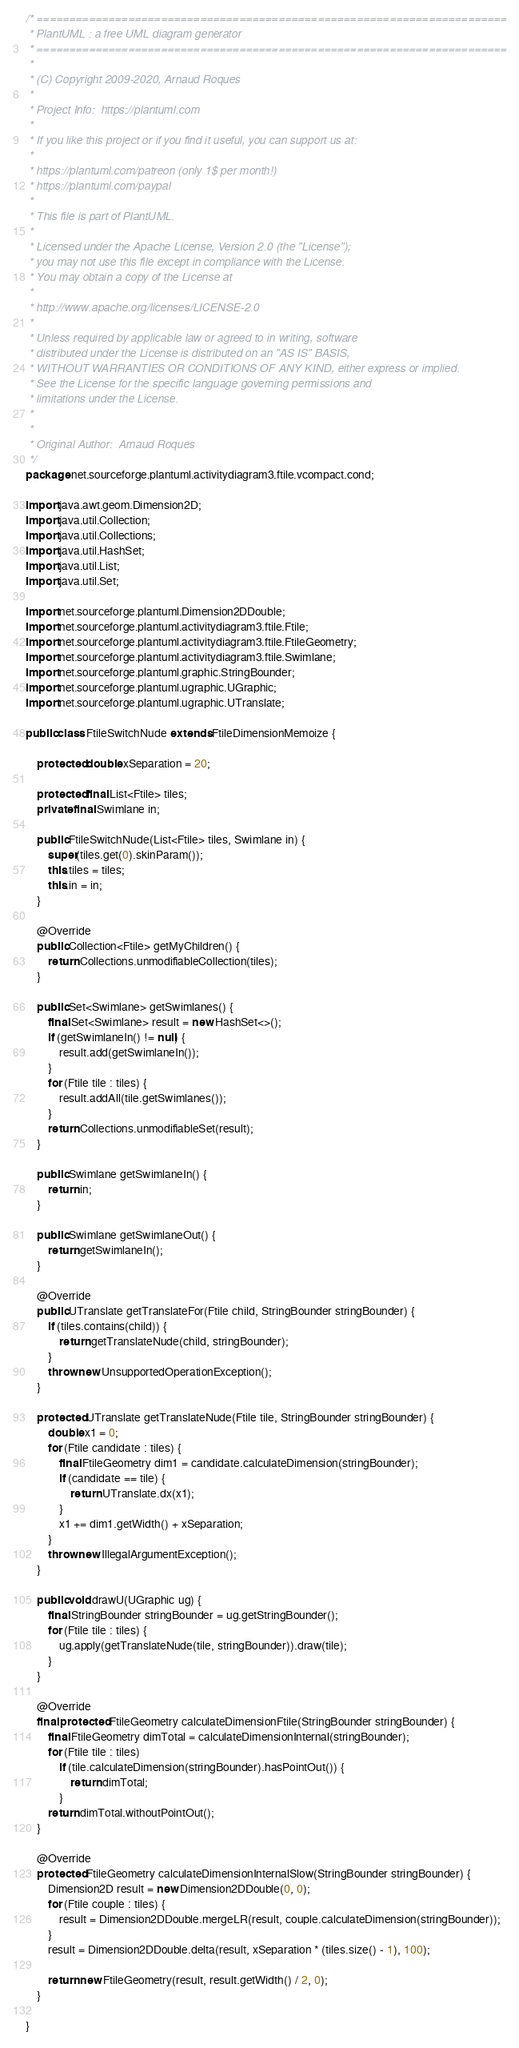Convert code to text. <code><loc_0><loc_0><loc_500><loc_500><_Java_>/* ========================================================================
 * PlantUML : a free UML diagram generator
 * ========================================================================
 *
 * (C) Copyright 2009-2020, Arnaud Roques
 *
 * Project Info:  https://plantuml.com
 * 
 * If you like this project or if you find it useful, you can support us at:
 * 
 * https://plantuml.com/patreon (only 1$ per month!)
 * https://plantuml.com/paypal
 * 
 * This file is part of PlantUML.
 *
 * Licensed under the Apache License, Version 2.0 (the "License");
 * you may not use this file except in compliance with the License.
 * You may obtain a copy of the License at
 * 
 * http://www.apache.org/licenses/LICENSE-2.0
 * 
 * Unless required by applicable law or agreed to in writing, software
 * distributed under the License is distributed on an "AS IS" BASIS,
 * WITHOUT WARRANTIES OR CONDITIONS OF ANY KIND, either express or implied.
 * See the License for the specific language governing permissions and
 * limitations under the License.
 *
 *
 * Original Author:  Arnaud Roques
 */
package net.sourceforge.plantuml.activitydiagram3.ftile.vcompact.cond;

import java.awt.geom.Dimension2D;
import java.util.Collection;
import java.util.Collections;
import java.util.HashSet;
import java.util.List;
import java.util.Set;

import net.sourceforge.plantuml.Dimension2DDouble;
import net.sourceforge.plantuml.activitydiagram3.ftile.Ftile;
import net.sourceforge.plantuml.activitydiagram3.ftile.FtileGeometry;
import net.sourceforge.plantuml.activitydiagram3.ftile.Swimlane;
import net.sourceforge.plantuml.graphic.StringBounder;
import net.sourceforge.plantuml.ugraphic.UGraphic;
import net.sourceforge.plantuml.ugraphic.UTranslate;

public class FtileSwitchNude extends FtileDimensionMemoize {

	protected double xSeparation = 20;

	protected final List<Ftile> tiles;
	private final Swimlane in;

	public FtileSwitchNude(List<Ftile> tiles, Swimlane in) {
		super(tiles.get(0).skinParam());
		this.tiles = tiles;
		this.in = in;
	}

	@Override
	public Collection<Ftile> getMyChildren() {
		return Collections.unmodifiableCollection(tiles);
	}

	public Set<Swimlane> getSwimlanes() {
		final Set<Swimlane> result = new HashSet<>();
		if (getSwimlaneIn() != null) {
			result.add(getSwimlaneIn());
		}
		for (Ftile tile : tiles) {
			result.addAll(tile.getSwimlanes());
		}
		return Collections.unmodifiableSet(result);
	}

	public Swimlane getSwimlaneIn() {
		return in;
	}

	public Swimlane getSwimlaneOut() {
		return getSwimlaneIn();
	}

	@Override
	public UTranslate getTranslateFor(Ftile child, StringBounder stringBounder) {
		if (tiles.contains(child)) {
			return getTranslateNude(child, stringBounder);
		}
		throw new UnsupportedOperationException();
	}

	protected UTranslate getTranslateNude(Ftile tile, StringBounder stringBounder) {
		double x1 = 0;
		for (Ftile candidate : tiles) {
			final FtileGeometry dim1 = candidate.calculateDimension(stringBounder);
			if (candidate == tile) {
				return UTranslate.dx(x1);
			}
			x1 += dim1.getWidth() + xSeparation;
		}
		throw new IllegalArgumentException();
	}

	public void drawU(UGraphic ug) {
		final StringBounder stringBounder = ug.getStringBounder();
		for (Ftile tile : tiles) {
			ug.apply(getTranslateNude(tile, stringBounder)).draw(tile);
		}
	}

	@Override
	final protected FtileGeometry calculateDimensionFtile(StringBounder stringBounder) {
		final FtileGeometry dimTotal = calculateDimensionInternal(stringBounder);
		for (Ftile tile : tiles)
			if (tile.calculateDimension(stringBounder).hasPointOut()) {
				return dimTotal;
			}
		return dimTotal.withoutPointOut();
	}

	@Override
	protected FtileGeometry calculateDimensionInternalSlow(StringBounder stringBounder) {
		Dimension2D result = new Dimension2DDouble(0, 0);
		for (Ftile couple : tiles) {
			result = Dimension2DDouble.mergeLR(result, couple.calculateDimension(stringBounder));
		}
		result = Dimension2DDouble.delta(result, xSeparation * (tiles.size() - 1), 100);

		return new FtileGeometry(result, result.getWidth() / 2, 0);
	}

}
</code> 